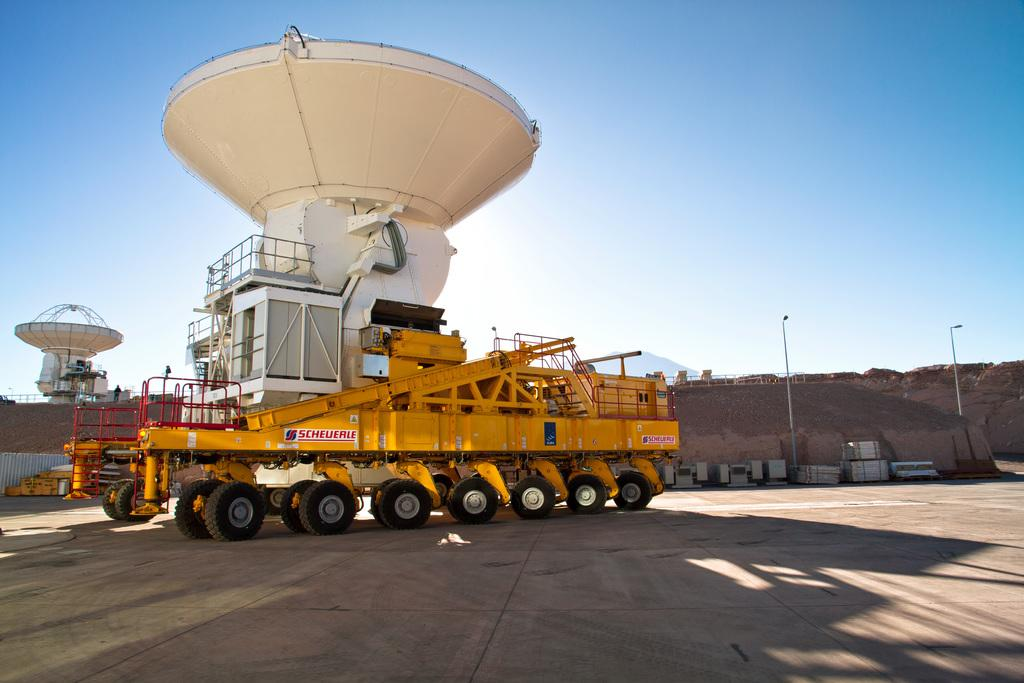What is the main subject of the image? The main subject of the image is a machine on a vehicle. What can be seen in the background of the image? There is equipment and soil in the background of the image, as well as the sky. What type of skirt is the cat wearing in the image? There is no cat or skirt present in the image. How many mice can be seen playing with the equipment in the background? There are no mice present in the image; only equipment and soil can be seen in the background. 